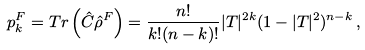<formula> <loc_0><loc_0><loc_500><loc_500>p _ { k } ^ { F } = T r \left ( \hat { C } \hat { \rho } ^ { F } \right ) = \frac { n ! } { k ! ( n - k ) ! } | T | ^ { 2 k } ( 1 - | T | ^ { 2 } ) ^ { n - k } \, ,</formula> 